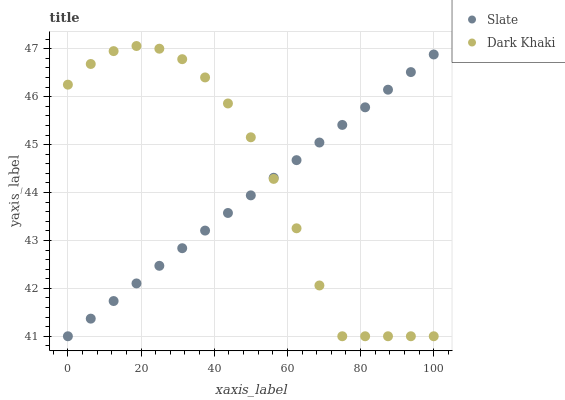Does Slate have the minimum area under the curve?
Answer yes or no. Yes. Does Dark Khaki have the maximum area under the curve?
Answer yes or no. Yes. Does Slate have the maximum area under the curve?
Answer yes or no. No. Is Slate the smoothest?
Answer yes or no. Yes. Is Dark Khaki the roughest?
Answer yes or no. Yes. Is Slate the roughest?
Answer yes or no. No. Does Dark Khaki have the lowest value?
Answer yes or no. Yes. Does Dark Khaki have the highest value?
Answer yes or no. Yes. Does Slate have the highest value?
Answer yes or no. No. Does Dark Khaki intersect Slate?
Answer yes or no. Yes. Is Dark Khaki less than Slate?
Answer yes or no. No. Is Dark Khaki greater than Slate?
Answer yes or no. No. 